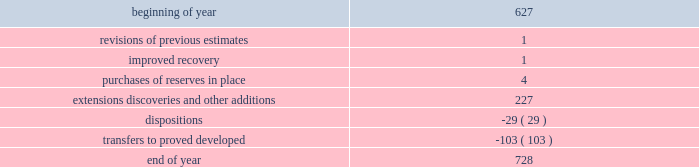During 2014 , 2013 and 2012 , netherland , sewell & associates , inc .
( "nsai" ) prepared a certification of the prior year's reserves for the alba field in e.g .
The nsai summary reports are filed as an exhibit to this annual report on form 10-k .
Members of the nsai team have multiple years of industry experience , having worked for large , international oil and gas companies before joining nsai .
The senior technical advisor has over 35 years of practical experience in petroleum geosciences , with over 15 years experience in the estimation and evaluation of reserves .
The second team member has over 10 years of practical experience in petroleum engineering , with 5 years experience in the estimation and evaluation of reserves .
Both are registered professional engineers in the state of texas .
Ryder scott company ( "ryder scott" ) also performed audits of the prior years' reserves of several of our fields in 2014 , 2013 and 2012 .
Their summary reports are filed as exhibits to this annual report on form 10-k .
The team lead for ryder scott has over 20 years of industry experience , having worked for a major international oil and gas company before joining ryder scott .
He is a member of spe , where he served on the oil and gas reserves committee , and is a registered professional engineer in the state of texas .
Changes in proved undeveloped reserves as of december 31 , 2014 , 728 mmboe of proved undeveloped reserves were reported , an increase of 101 mmboe from december 31 , 2013 .
The table shows changes in total proved undeveloped reserves for 2014 : ( mmboe ) .
Significant additions to proved undeveloped reserves during 2014 included 121 mmboe in the eagle ford and 61 mmboe in the bakken shale plays due to development drilling .
Transfers from proved undeveloped to proved developed reserves included 67 mmboe in the eagle ford , 26 mmboe in the bakken and 1 mmboe in the oklahoma resource basins due to development drilling and completions .
Costs incurred in 2014 , 2013 and 2012 relating to the development of proved undeveloped reserves , were $ 3149 million , $ 2536 million and $ 1995 million .
A total of 102 mmboe was booked as extensions , discoveries or other additions due to the application of reliable technology .
Technologies included statistical analysis of production performance , decline curve analysis , pressure and rate transient analysis , reservoir simulation and volumetric analysis .
The statistical nature of production performance coupled with highly certain reservoir continuity or quality within the reliable technology areas and sufficient proved undeveloped locations establish the reasonable certainty criteria required for booking proved reserves .
Projects can remain in proved undeveloped reserves for extended periods in certain situations such as large development projects which take more than five years to complete , or the timing of when additional gas compression is needed .
Of the 728 mmboe of proved undeveloped reserves at december 31 , 2014 , 19 percent of the volume is associated with projects that have been included in proved reserves for more than five years .
The majority of this volume is related to a compression project in e.g .
That was sanctioned by our board of directors in 2004 .
The timing of the installation of compression is being driven by the reservoir performance with this project intended to maintain maximum production levels .
Performance of this field since the board sanctioned the project has far exceeded expectations .
Estimates of initial dry gas in place increased by roughly 10 percent between 2004 and 2010 .
During 2012 , the compression project received the approval of the e.g .
Government , allowing design and planning work to progress towards implementation , with completion expected by mid-2016 .
The other component of alba proved undeveloped reserves is an infill well approved in 2013 and to be drilled in the second quarter of 2015 .
Proved undeveloped reserves for the north gialo development , located in the libyan sahara desert , were booked for the first time in 2010 .
This development , which is anticipated to take more than five years to develop , is executed by the operator and encompasses a multi-year drilling program including the design , fabrication and installation of extensive liquid handling and gas recycling facilities .
Anecdotal evidence from similar development projects in the region lead to an expected project execution time frame of more than five years from the time the reserves were initially booked .
Interruptions associated with the civil unrest in 2011 and third-party labor strikes and civil unrest in 2013-2014 have also extended the project duration .
As of december 31 , 2014 , future development costs estimated to be required for the development of proved undeveloped crude oil and condensate , ngls , natural gas and synthetic crude oil reserves related to continuing operations for the years 2015 through 2019 are projected to be $ 2915 million , $ 2598 million , $ 2493 million , $ 2669 million and $ 2745 million. .
What was the decrease in undeveloped reserves due to dispositions and \\ntransfers to proved developed reserves , in mmboe? 
Computations: ((29 * const_m1) + -103)
Answer: -132.0. 